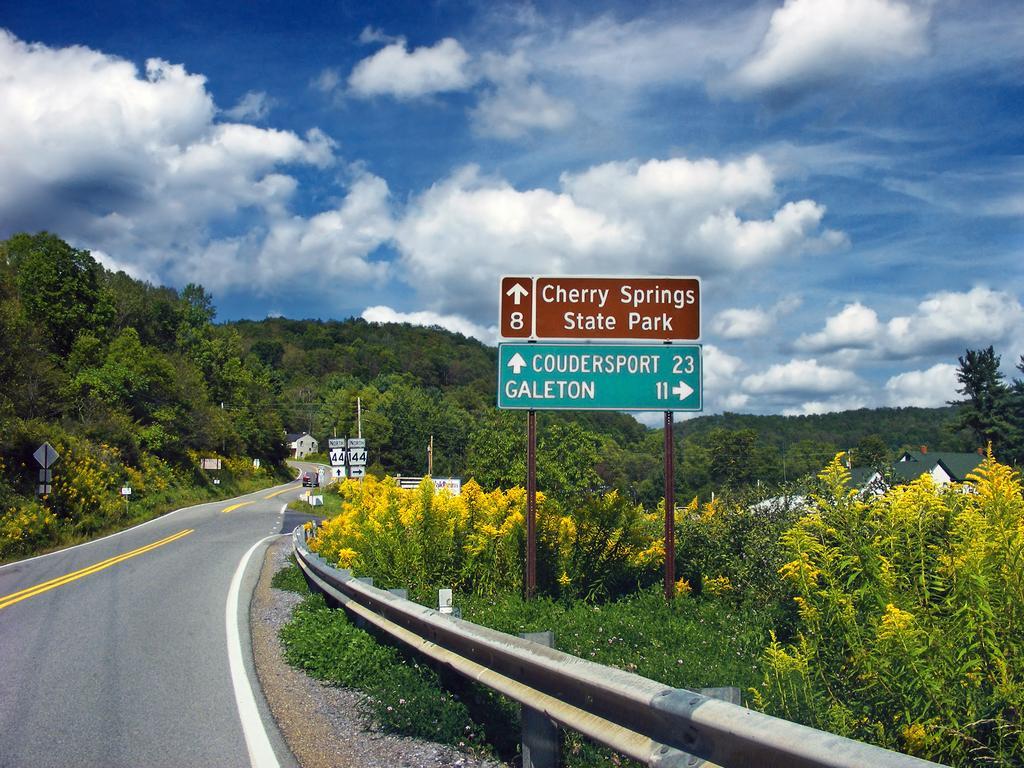Can you describe this image briefly? In this image there is the sky towards the top of the image, there are clouds in the sky, there are trees, there are houses, there is a road towards the left of the image, there is a car on the road, there are poles, there are boards, there is text on the boards, there are numbers on the boards, there is a metal fence towards the bottom of the image, there are plants, there are flowers. 